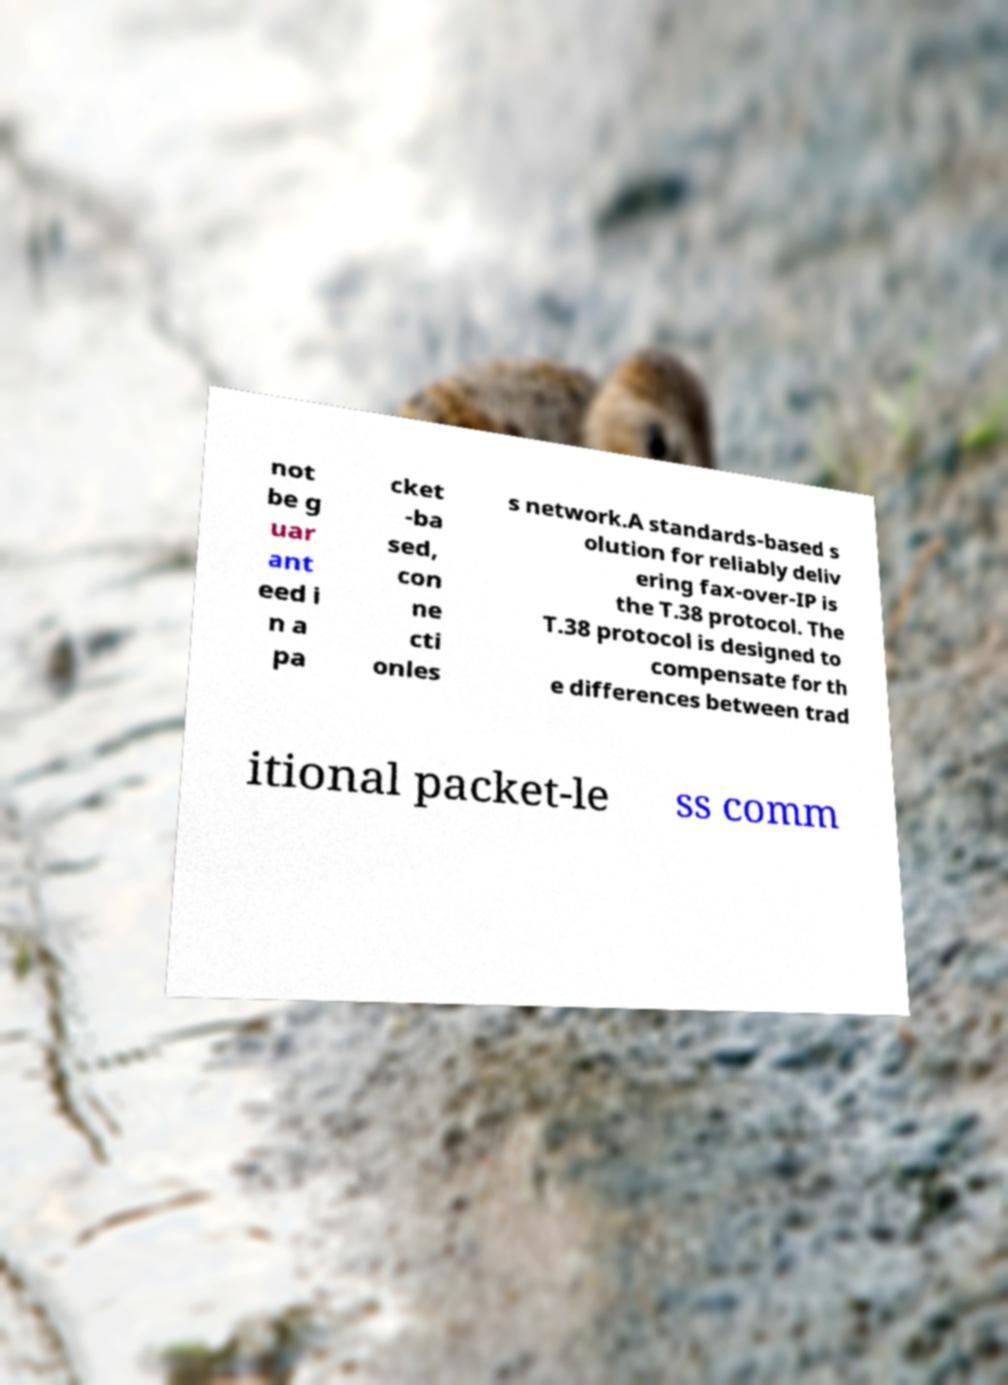I need the written content from this picture converted into text. Can you do that? not be g uar ant eed i n a pa cket -ba sed, con ne cti onles s network.A standards-based s olution for reliably deliv ering fax-over-IP is the T.38 protocol. The T.38 protocol is designed to compensate for th e differences between trad itional packet-le ss comm 